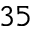<formula> <loc_0><loc_0><loc_500><loc_500>3 5</formula> 